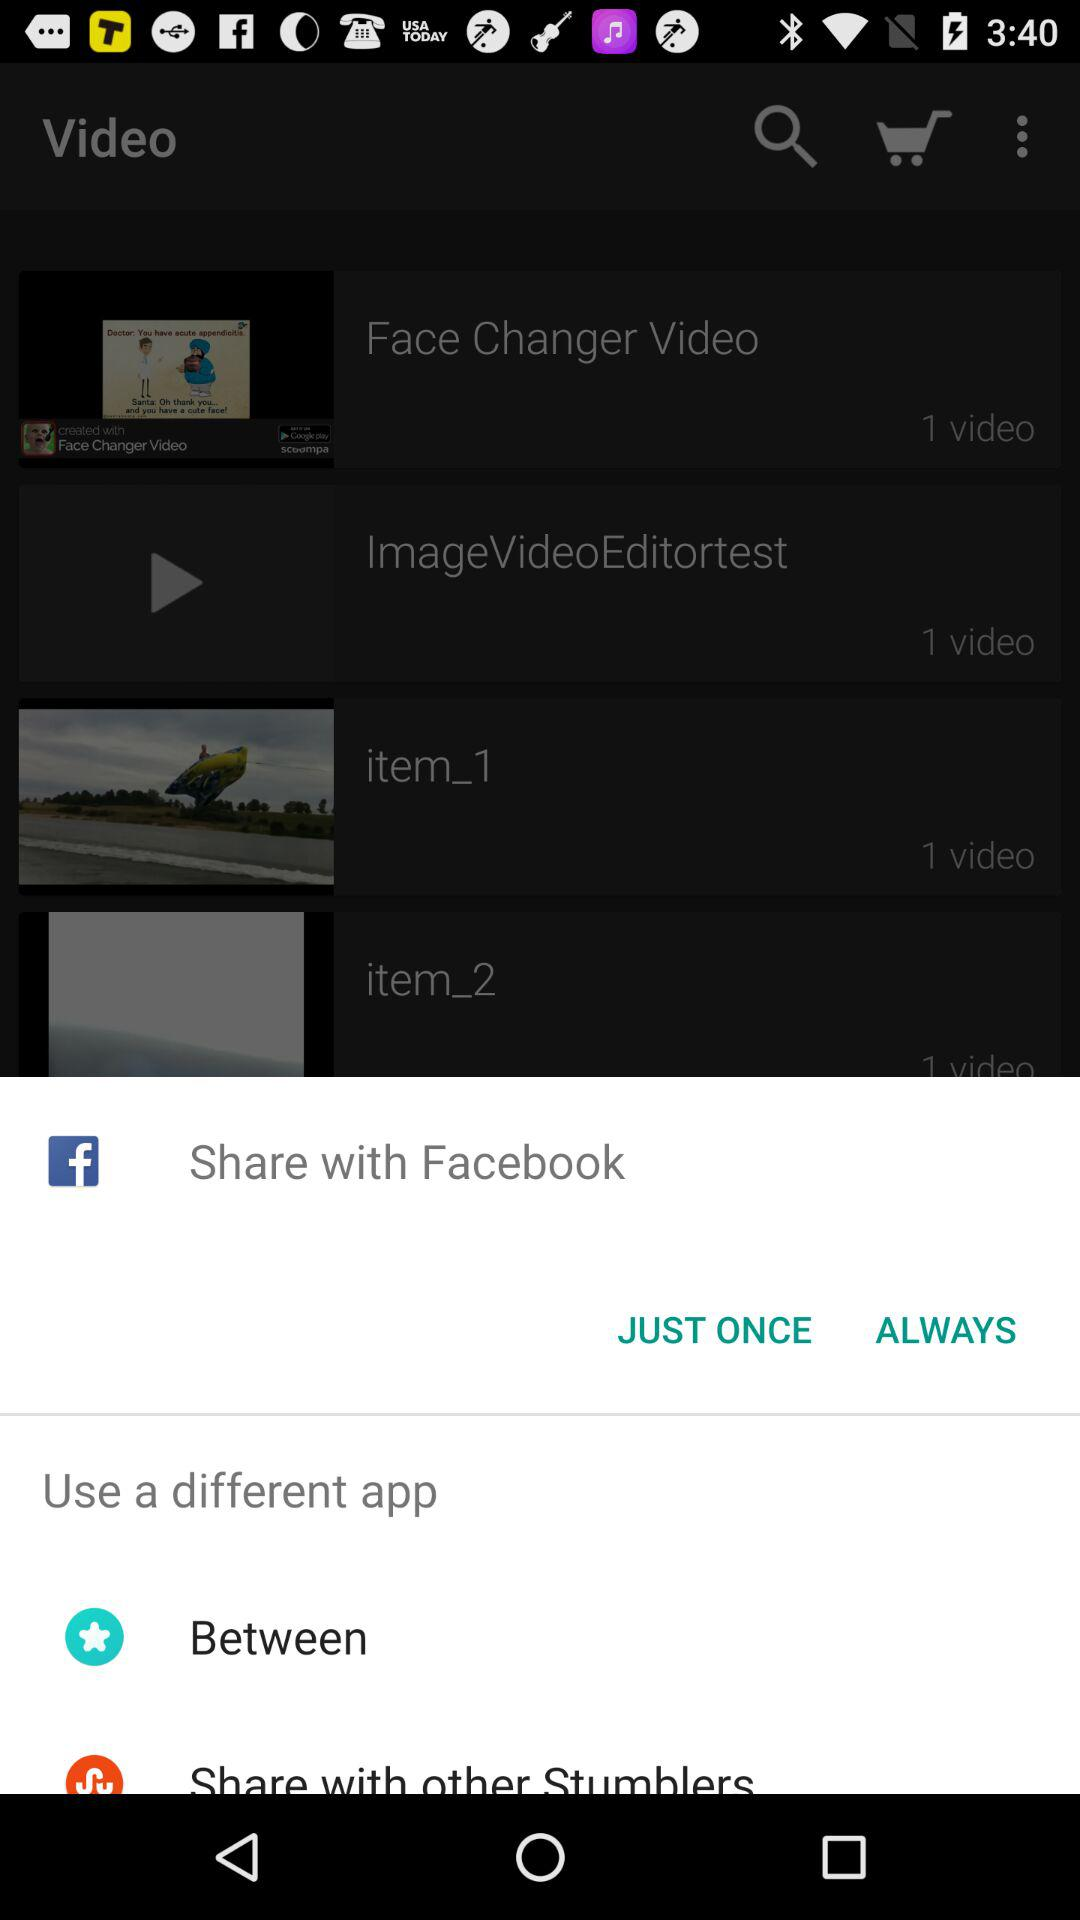With which different options can the content be shared? The content can be shared with "Facebook", "Between" and "Share with other Stumblers". 